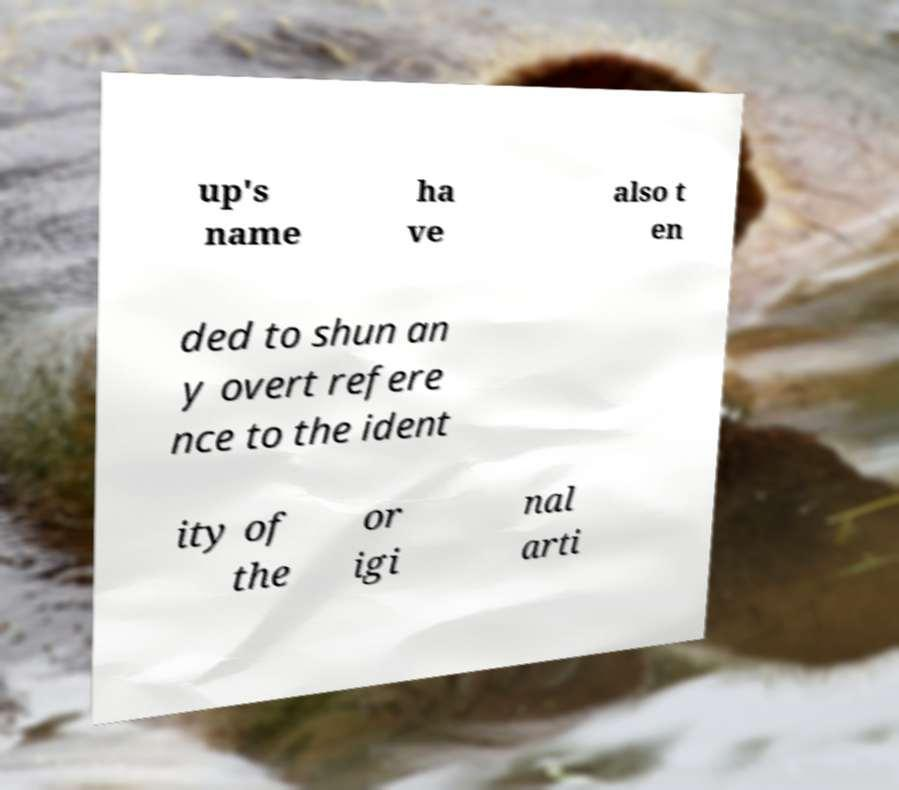Can you accurately transcribe the text from the provided image for me? up's name ha ve also t en ded to shun an y overt refere nce to the ident ity of the or igi nal arti 